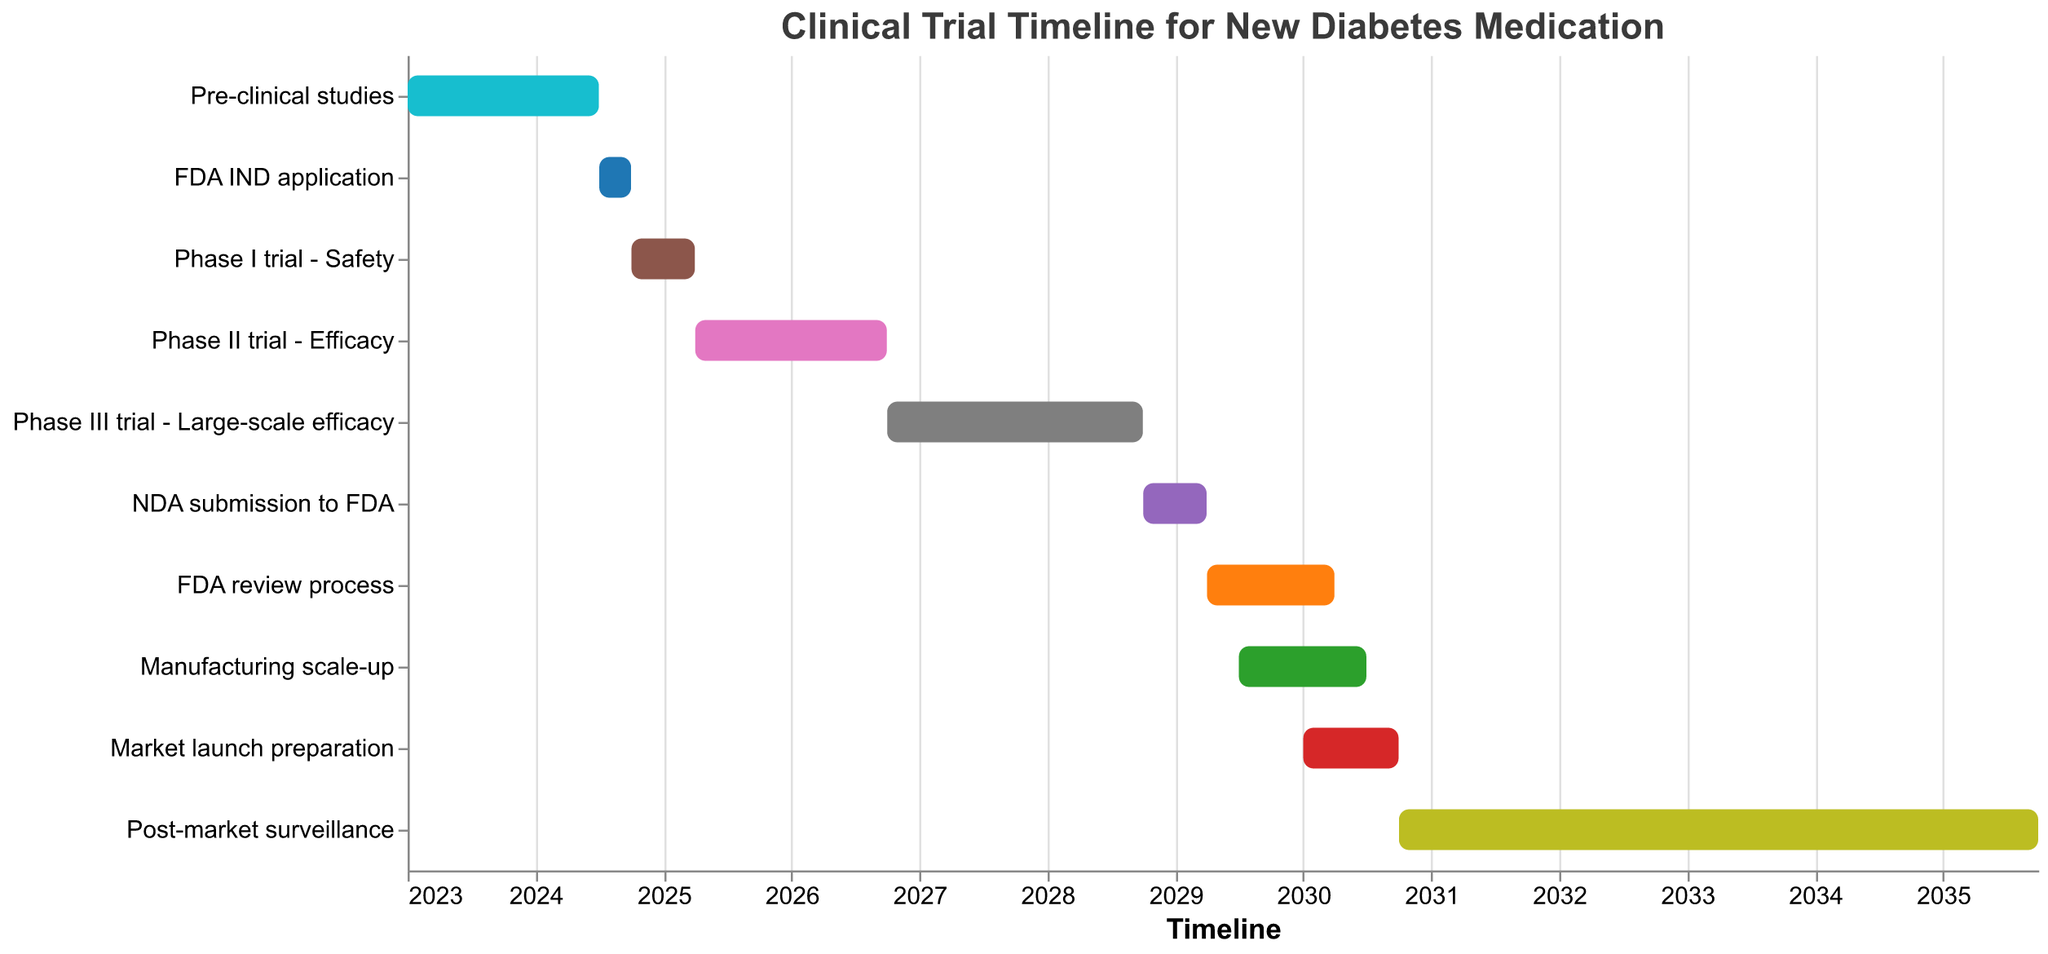Which task starts at the earliest date? The task that starts at the earliest date can be identified by looking at the leftmost bar on the Gantt Chart. This bar represents the "Pre-clinical studies," which starts on January 1, 2023.
Answer: Pre-clinical studies How long does the Phase III trial last? To find the duration of the Phase III trial, we need to calculate the difference between its start and end dates. It starts on October 1, 2026, and ends on September 30, 2028. The duration is 2 years (October 2026 to October 2027, and October 2027 to October 2028).
Answer: 2 years What is the total duration for the entire clinical trial process up to market launch preparation? We need to calculate the total duration from the start of "Pre-clinical studies" (January 1, 2023) to the end of "Market launch preparation" (September 30, 2030). This involves adding up the years from 2023 to 2030.
Answer: 7 years and 9 months Which task overlaps with the NDA submission to FDA? To find tasks that overlap with "NDA submission to FDA" (October 1, 2028 to March 31, 2029), we see that "FDA review process" (starting April 1, 2029) and "Manufacturing scale-up" (starting July 1, 2029) overlap with it.
Answer: None Compared to the Phase II trial, does the Phase I trial last longer? The Phase I trial lasts from October 1, 2024, to March 31, 2025, which is 6 months. The Phase II trial lasts from April 1, 2025, to September 30, 2026, which is 1 year and 6 months. Thus, the Phase II trial is longer.
Answer: No Which phase has the shortest duration? By comparing the durations of all phases, we see that the "FDA IND application" (July 1, 2024, to September 30, 2024) lasts only 3 months, making it the shortest.
Answer: FDA IND application What is the duration between the start of the FDA review process to the end of market launch preparation? The FDA review process starts on April 1, 2029, and the market launch preparation ends on September 30, 2030. The duration between these two dates is 1 year and 6 months.
Answer: 1 year and 6 months When does post-market surveillance end, and how long does it last? Post-market surveillance ends on September 30, 2035, and it starts on October 1, 2030, lasting 5 years.
Answer: September 30, 2035; 5 years What color is used to represent the Phase I trial? In the Gantt Chart, the Phase I trial is represented by the color blue.
Answer: Blue 